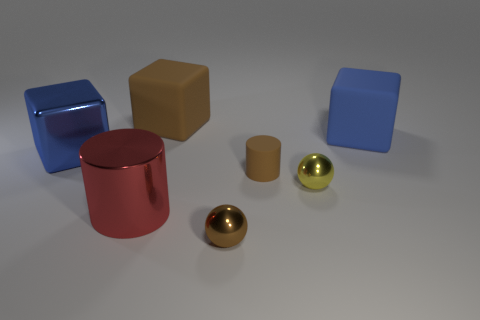There is a red metallic object that is the same size as the blue shiny thing; what is its shape?
Your response must be concise. Cylinder. Are there any matte cubes that have the same color as the big metallic block?
Provide a short and direct response. Yes. Do the matte cylinder and the shiny sphere that is in front of the red metal object have the same color?
Keep it short and to the point. Yes. The rubber cube in front of the big rubber cube to the left of the yellow thing is what color?
Offer a very short reply. Blue. Is there a small metal ball in front of the cylinder that is on the left side of the brown rubber thing on the right side of the brown metal thing?
Make the answer very short. Yes. What is the color of the big cylinder that is made of the same material as the brown sphere?
Give a very brief answer. Red. What number of blue blocks have the same material as the small yellow object?
Provide a succinct answer. 1. Does the big red thing have the same material as the yellow ball in front of the big brown thing?
Your answer should be very brief. Yes. What number of things are blue objects that are behind the big blue shiny thing or big matte objects?
Offer a terse response. 2. There is a cube that is behind the big matte thing that is in front of the brown matte object behind the tiny cylinder; what size is it?
Your response must be concise. Large. 